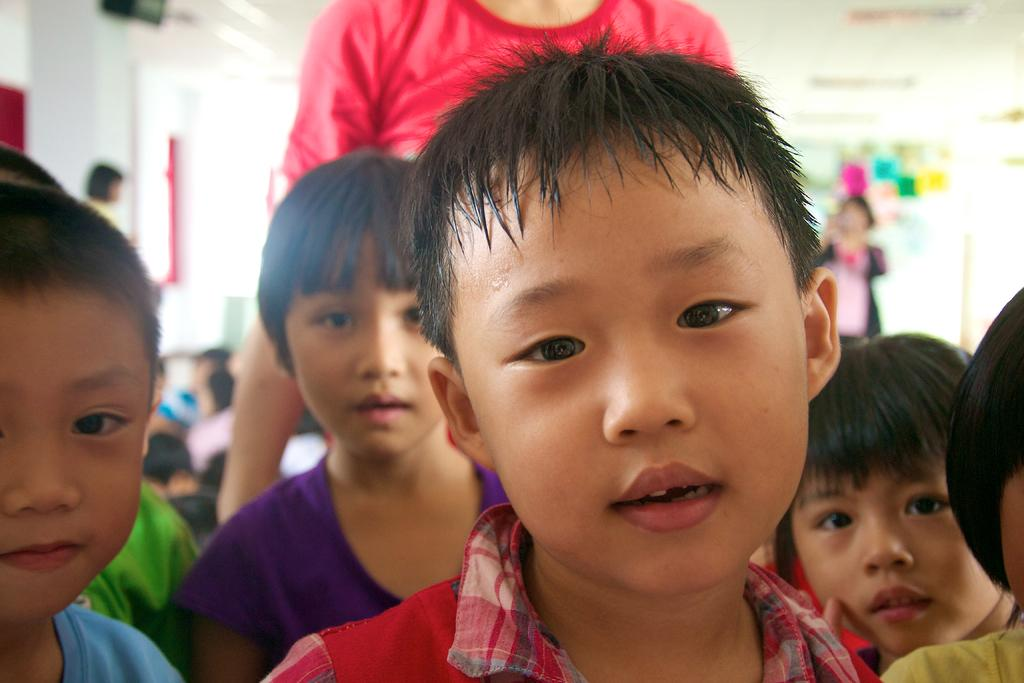What is the main subject of the image? The main subject of the image is little kids in the center. What can be seen in the background of the image? In the background, there is a wall, a roof, boards, notes, people sitting, and people standing. How many elements are present in the background of the image? There are six elements present in the background: a wall, a roof, boards, notes, people sitting, and people standing. What type of lead is being followed by the kids in the image? There is no indication of a lead or any activity involving a lead in the image. Can you see a railway in the image? No, there is no railway present in the image. 